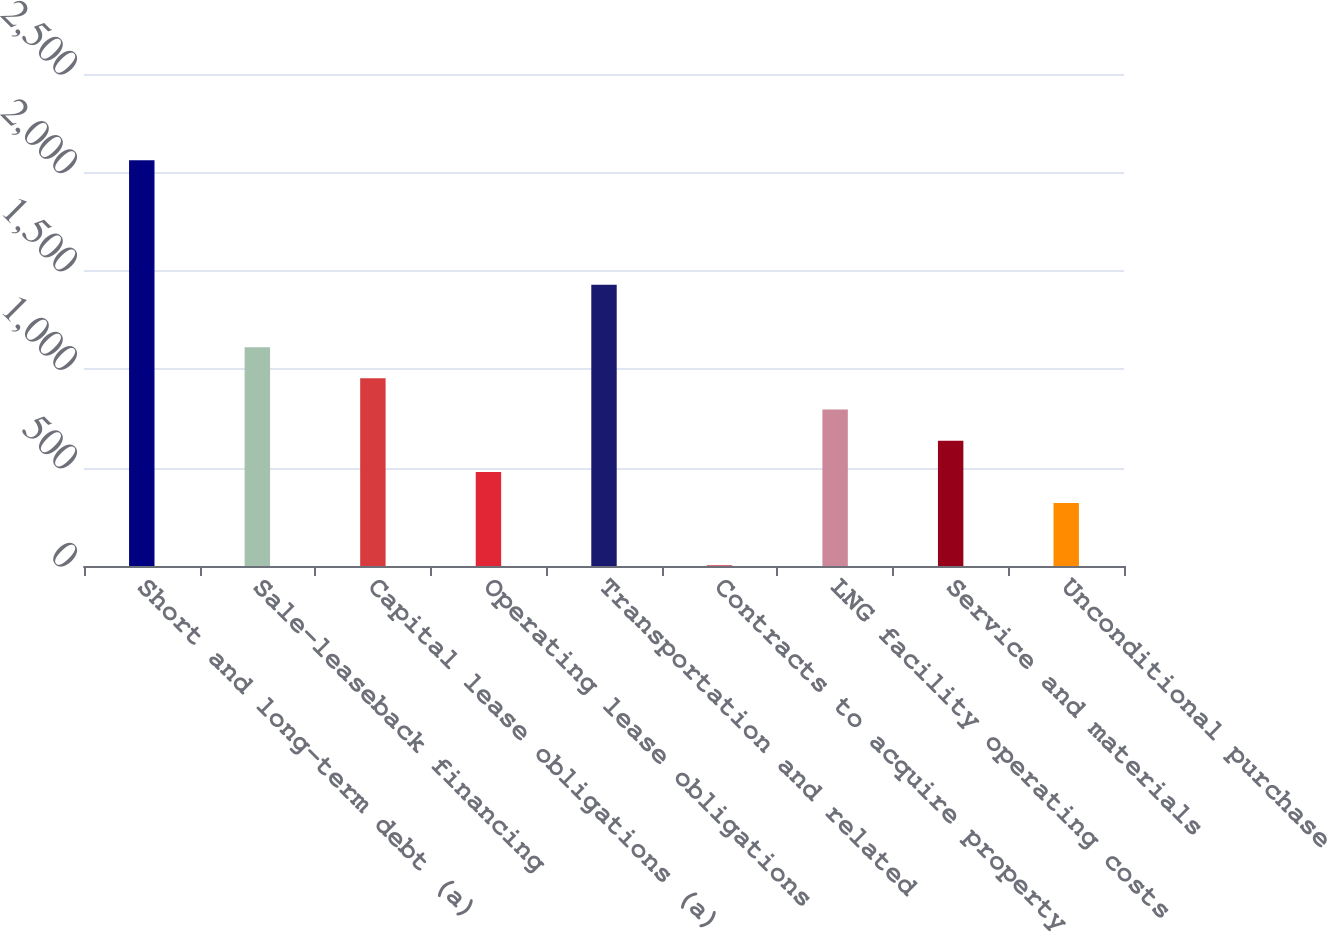<chart> <loc_0><loc_0><loc_500><loc_500><bar_chart><fcel>Short and long-term debt (a)<fcel>Sale-leaseback financing<fcel>Capital lease obligations (a)<fcel>Operating lease obligations<fcel>Transportation and related<fcel>Contracts to acquire property<fcel>LNG facility operating costs<fcel>Service and materials<fcel>Unconditional purchase<nl><fcel>2062.2<fcel>1111.8<fcel>953.4<fcel>478.2<fcel>1428.6<fcel>3<fcel>795<fcel>636.6<fcel>319.8<nl></chart> 